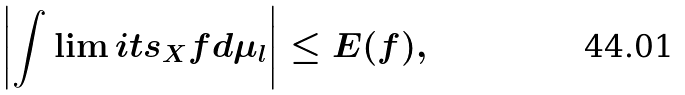<formula> <loc_0><loc_0><loc_500><loc_500>\left | \int \lim i t s _ { X } f d \mu _ { l } \right | \leq E ( f ) ,</formula> 